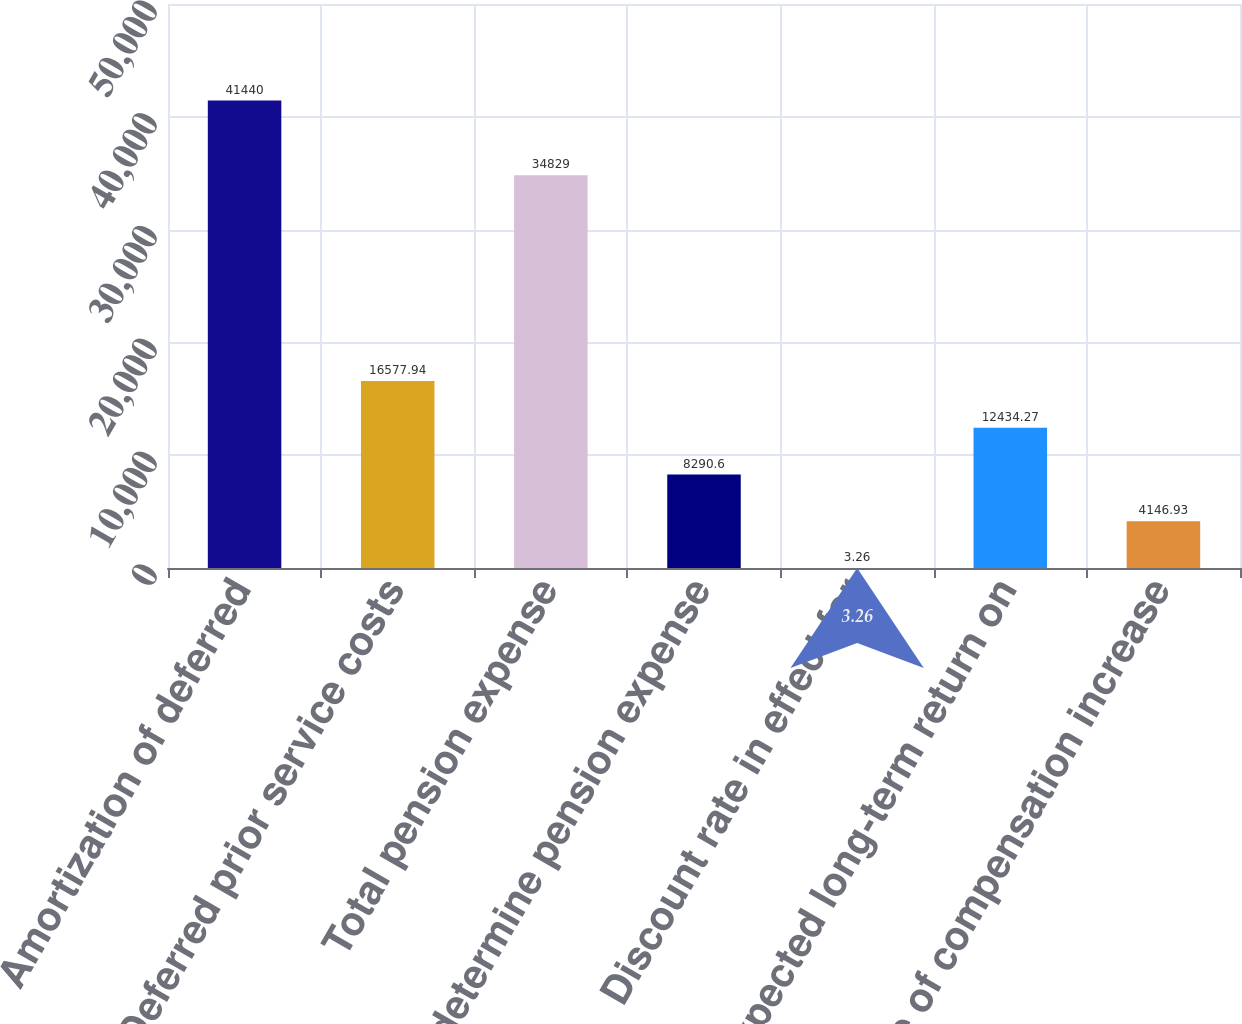<chart> <loc_0><loc_0><loc_500><loc_500><bar_chart><fcel>Amortization of deferred<fcel>Deferred prior service costs<fcel>Total pension expense<fcel>determine pension expense<fcel>Discount rate in effect for<fcel>Expected long-term return on<fcel>Rate of compensation increase<nl><fcel>41440<fcel>16577.9<fcel>34829<fcel>8290.6<fcel>3.26<fcel>12434.3<fcel>4146.93<nl></chart> 